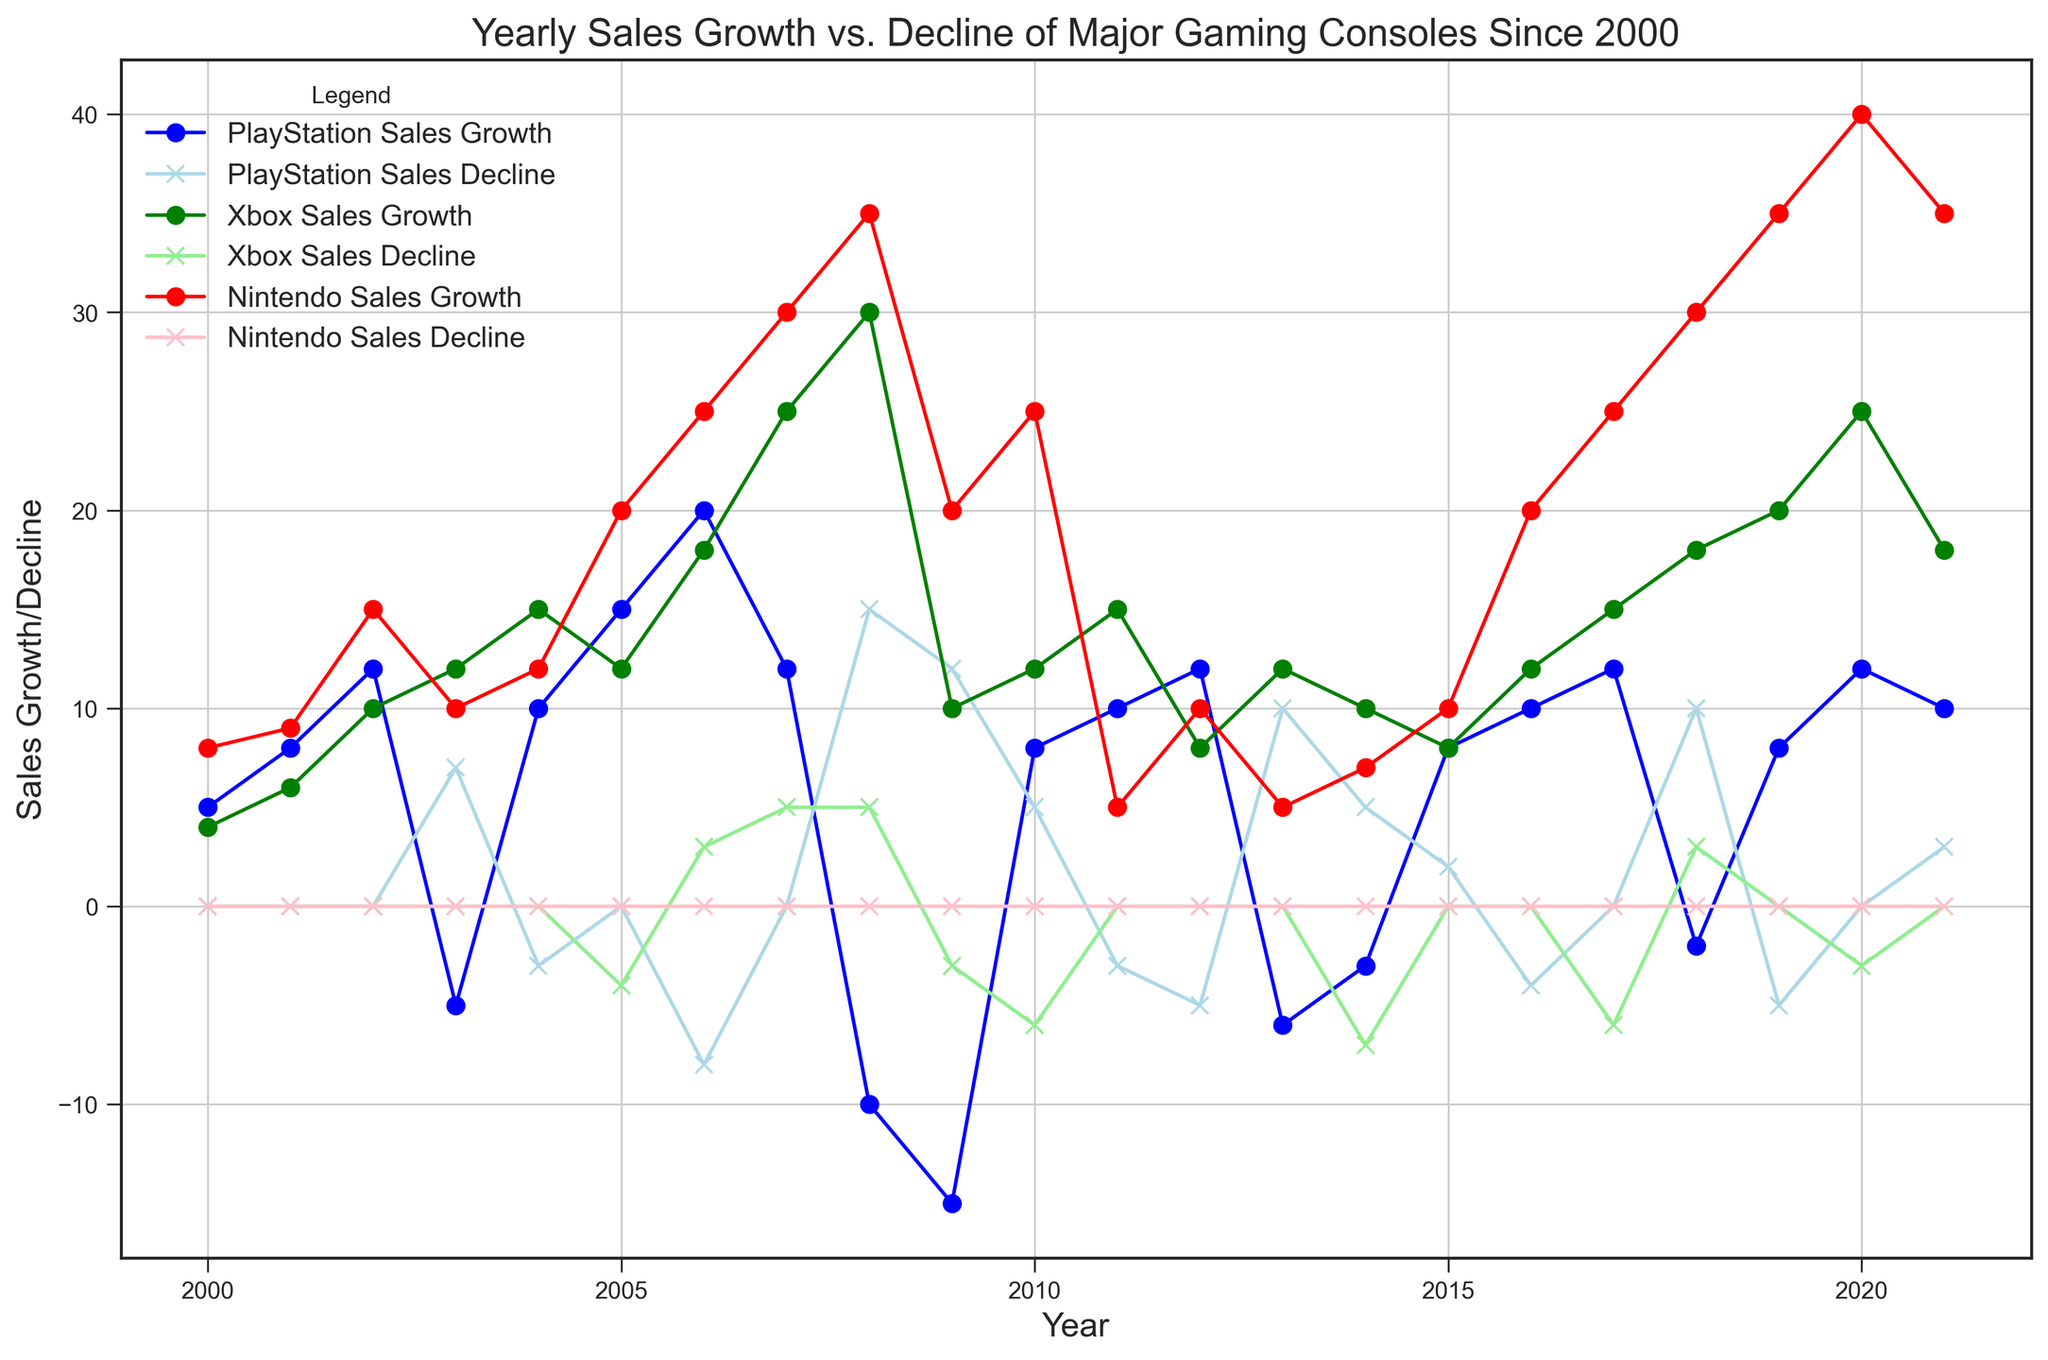What year did PlayStation experience the highest sales growth? Refer to the PlayStation Sales Growth line (blue line with circles). The highest point on this line represents the maximum sales growth. This occurs in 2006.
Answer: 2006 Which console had the highest sales growth in 2020? Look at the data points for 2020 on the Sales Growth lines for PlayStation (blue), Xbox (green), and Nintendo (red). The highest value is on the red line (Nintendo Sales Growth), which shows 40.
Answer: Nintendo Comparing PlayStation and Xbox, which one had more years with a sales decline since 2000? Identify the years with sales decline for PlayStation (light blue line with x's) and Xbox (light green line with x's). PlayStation had declines in 2003, 2004, 2006, 2008, 2009, 2010, 2011, 2012, 2013, 2014, 2015, 2016, 2018, 2019, and 2021 (15 years). Xbox had declines in 2005, 2006, 2007, 2008, 2009, 2010, 2011, 2014, 2017, 2018, and 2020 (11 years). So, PlayStation had more years with sales decline.
Answer: PlayStation In what year did both PlayStation and Nintendo experience a sales decline, but Xbox experienced sales growth? Find a year when both the light blue line (PlayStation Sales Decline) and the pink line (Nintendo Sales Decline) have positive values and the green line (Xbox Sales Growth) is positive. In 2009, PlayStation and Nintendo both show declines, while Xbox shows growth.
Answer: 2009 What is the average sales growth for Xbox from 2000 to 2010? Find the Xbox Sales Growth values from 2000 to 2010 and then calculate the average. The values are 4, 6, 10, 12, 15, 12, 18, 25, 30, 10, 12. Sum these values: 4 + 6 + 10 + 12 + 15 + 12 + 18 + 25 + 30 + 10 + 12 = 154. Then, divide by the number of years (11). 154 / 11 = 14.
Answer: 14 When did Xbox experience its first sales decline? Look at the Xbox Sales Decline line (light green with x's). The first non-zero value appears in 2005.
Answer: 2005 